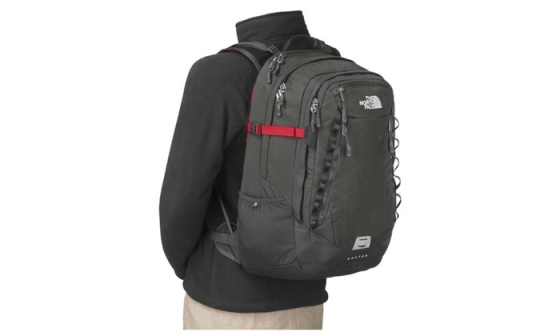Can you elaborate on the elements of the picture provided? The image features a person viewed from the back, dressed in a black jacket and beige trousers. The main highlight of the picture is a black North Face backpack worn by the individual. A striking feature is the red strap that crosses the chest, providing a contrast to the otherwise monochromatic outfit. The backpack is highly functional, showcasing multiple compartments and zippers that suggest ample storage capacity. The white North Face logo prominently displayed on the front pocket stands out against the black material. The overall setting is a minimalistic white backdrop, which accentuates the backpack and the attire of the person, drawing attention to the detailed features of the backpack and its design. 